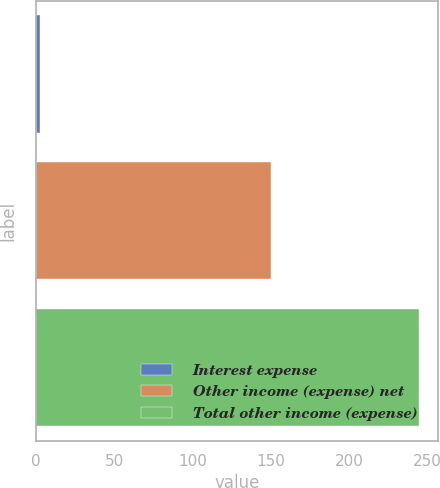Convert chart. <chart><loc_0><loc_0><loc_500><loc_500><bar_chart><fcel>Interest expense<fcel>Other income (expense) net<fcel>Total other income (expense)<nl><fcel>2.8<fcel>149.8<fcel>244.3<nl></chart> 